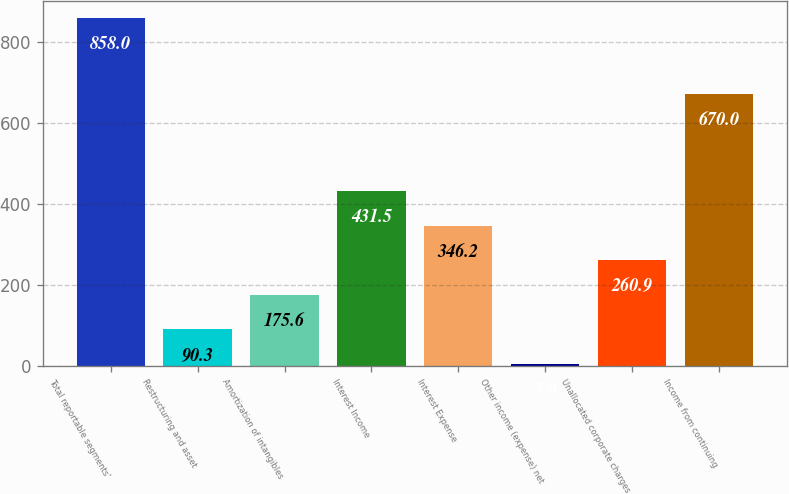Convert chart to OTSL. <chart><loc_0><loc_0><loc_500><loc_500><bar_chart><fcel>Total reportable segments'<fcel>Restructuring and asset<fcel>Amortization of intangibles<fcel>Interest Income<fcel>Interest Expense<fcel>Other income (expense) net<fcel>Unallocated corporate charges<fcel>Income from continuing<nl><fcel>858<fcel>90.3<fcel>175.6<fcel>431.5<fcel>346.2<fcel>5<fcel>260.9<fcel>670<nl></chart> 